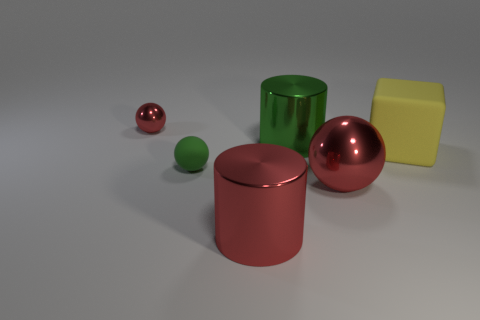There is another sphere that is the same color as the big sphere; what size is it?
Provide a succinct answer. Small. How many other things are the same color as the large metallic sphere?
Keep it short and to the point. 2. What material is the large red thing that is the same shape as the small red object?
Ensure brevity in your answer.  Metal. Are there any other things that have the same color as the large ball?
Provide a succinct answer. Yes. There is a tiny thing that is the same color as the large metallic sphere; what is its shape?
Offer a very short reply. Sphere. Do the big metal cylinder behind the yellow cube and the matte ball have the same color?
Offer a very short reply. Yes. Are there the same number of tiny metal balls that are left of the large yellow cube and rubber balls?
Ensure brevity in your answer.  Yes. Is the material of the cylinder that is behind the large red cylinder the same as the small ball in front of the large yellow thing?
Provide a short and direct response. No. There is a green rubber thing on the right side of the red object behind the green rubber sphere; what shape is it?
Offer a very short reply. Sphere. What is the color of the sphere that is the same material as the large cube?
Give a very brief answer. Green. 